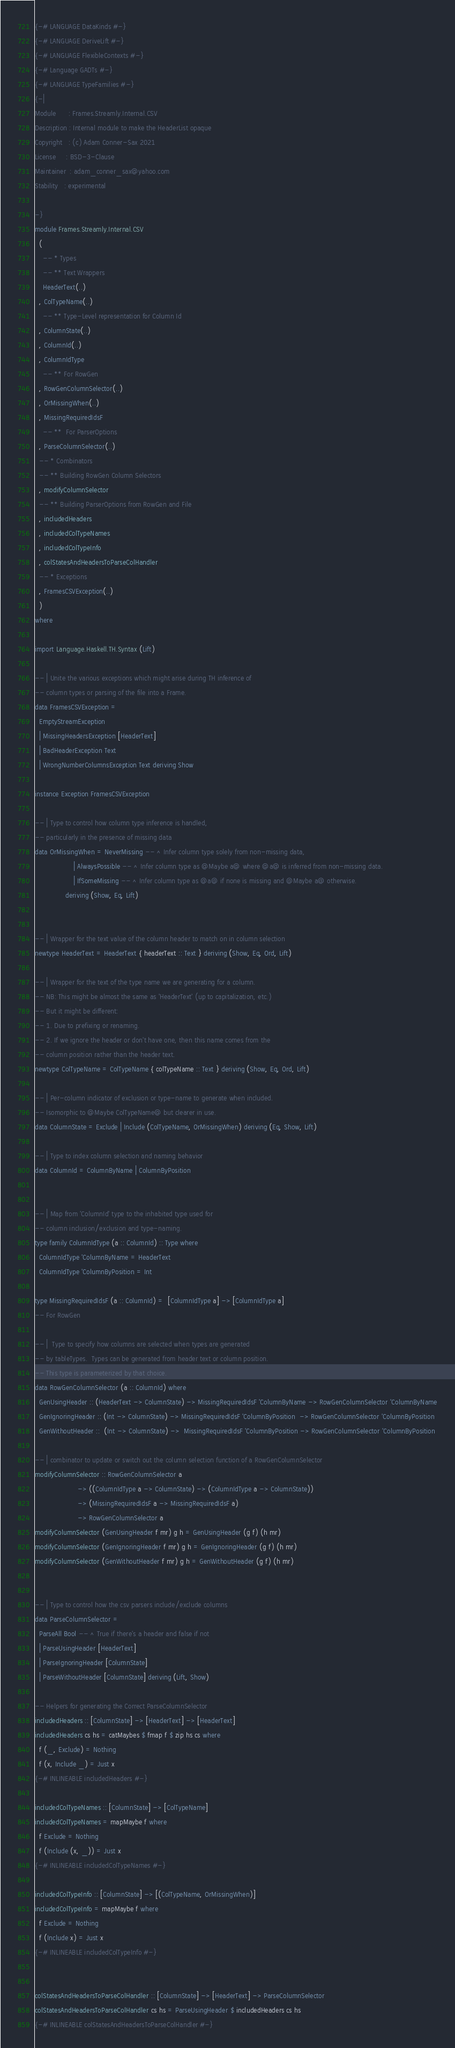Convert code to text. <code><loc_0><loc_0><loc_500><loc_500><_Haskell_>{-# LANGUAGE DataKinds #-}
{-# LANGUAGE DeriveLift #-}
{-# LANGUAGE FlexibleContexts #-}
{-# Language GADTs #-}
{-# LANGUAGE TypeFamilies #-}
{-|
Module      : Frames.Streamly.Internal.CSV
Description : Internal module to make the HeaderList opaque
Copyright   : (c) Adam Conner-Sax 2021
License     : BSD-3-Clause
Maintainer  : adam_conner_sax@yahoo.com
Stability   : experimental

-}
module Frames.Streamly.Internal.CSV
  (
    -- * Types
    -- ** Text Wrappers
    HeaderText(..)
  , ColTypeName(..)
    -- ** Type-Level representation for Column Id
  , ColumnState(..)
  , ColumnId(..)
  , ColumnIdType
    -- ** For RowGen
  , RowGenColumnSelector(..)
  , OrMissingWhen(..)
  , MissingRequiredIdsF
    -- **  For ParserOptions
  , ParseColumnSelector(..)
  -- * Combinators
  -- ** Building RowGen Column Selectors
  , modifyColumnSelector
  -- ** Building ParserOptions from RowGen and File
  , includedHeaders
  , includedColTypeNames
  , includedColTypeInfo
  , colStatesAndHeadersToParseColHandler
  -- * Exceptions
  , FramesCSVException(..)
  )
where

import Language.Haskell.TH.Syntax (Lift)

-- | Unite the various exceptions which might arise during TH inference of
-- column types or parsing of the file into a Frame.
data FramesCSVException =
  EmptyStreamException
  | MissingHeadersException [HeaderText]
  | BadHeaderException Text
  | WrongNumberColumnsException Text deriving Show

instance Exception FramesCSVException

-- | Type to control how column type inference is handled,
-- particularly in the presence of missing data
data OrMissingWhen = NeverMissing -- ^ Infer column type solely from non-missing data,
                   | AlwaysPossible -- ^ Infer column type as @Maybe a@ where @a@ is inferred from non-missing data.
                   | IfSomeMissing -- ^ Infer column type as @a@ if none is missing and @Maybe a@ otherwise.
               deriving (Show, Eq, Lift)


-- | Wrapper for the text value of the column header to match on in column selection
newtype HeaderText = HeaderText { headerText :: Text } deriving (Show, Eq, Ord, Lift)

-- | Wrapper for the text of the type name we are generating for a column.
-- NB: This might be almost the same as 'HeaderText' (up to capitalization, etc.)
-- But it might be different:
-- 1. Due to prefixing or renaming.
-- 2. If we ignore the header or don't have one, then this name comes from the
-- column position rather than the header text.
newtype ColTypeName = ColTypeName { colTypeName :: Text } deriving (Show, Eq, Ord, Lift)

-- | Per-column indicator of exclusion or type-name to generate when included.
-- Isomorphic to @Maybe ColTypeName@ but clearer in use.
data ColumnState = Exclude | Include (ColTypeName, OrMissingWhen) deriving (Eq, Show, Lift)

-- | Type to index column selection and naming behavior
data ColumnId = ColumnByName | ColumnByPosition


-- | Map from 'ColumnId' type to the inhabited type used for
-- column inclusion/exclusion and type-naming.
type family ColumnIdType (a :: ColumnId) :: Type where
  ColumnIdType 'ColumnByName = HeaderText
  ColumnIdType 'ColumnByPosition = Int

type MissingRequiredIdsF (a :: ColumnId) =  [ColumnIdType a] -> [ColumnIdType a]
-- For RowGen

-- |  Type to specify how columns are selected when types are generated
-- by tableTypes.  Types can be generated from header text or column position.
-- This type is parameterized by that choice.
data RowGenColumnSelector (a :: ColumnId) where
  GenUsingHeader :: (HeaderText -> ColumnState) -> MissingRequiredIdsF 'ColumnByName -> RowGenColumnSelector 'ColumnByName
  GenIgnoringHeader :: (Int -> ColumnState) -> MissingRequiredIdsF 'ColumnByPosition  -> RowGenColumnSelector 'ColumnByPosition
  GenWithoutHeader ::  (Int -> ColumnState) ->  MissingRequiredIdsF 'ColumnByPosition -> RowGenColumnSelector 'ColumnByPosition

-- | combinator to update or switch out the column selection function of a RowGenColumnSelector
modifyColumnSelector :: RowGenColumnSelector a
                     -> ((ColumnIdType a -> ColumnState) -> (ColumnIdType a -> ColumnState))
                     -> (MissingRequiredIdsF a -> MissingRequiredIdsF a)
                     -> RowGenColumnSelector a
modifyColumnSelector (GenUsingHeader f mr) g h = GenUsingHeader (g f) (h mr)
modifyColumnSelector (GenIgnoringHeader f mr) g h = GenIgnoringHeader (g f) (h mr)
modifyColumnSelector (GenWithoutHeader f mr) g h = GenWithoutHeader (g f) (h mr)


-- | Type to control how the csv parsers include/exclude columns
data ParseColumnSelector =
  ParseAll Bool -- ^ True if there's a header and false if not
  | ParseUsingHeader [HeaderText]
  | ParseIgnoringHeader [ColumnState]
  | ParseWithoutHeader [ColumnState] deriving (Lift, Show)

-- Helpers for generating the Correct ParseColumnSelector
includedHeaders :: [ColumnState] -> [HeaderText] -> [HeaderText]
includedHeaders cs hs = catMaybes $ fmap f $ zip hs cs where
  f (_, Exclude) = Nothing
  f (x, Include _) = Just x
{-# INLINEABLE includedHeaders #-}

includedColTypeNames :: [ColumnState] -> [ColTypeName]
includedColTypeNames = mapMaybe f where
  f Exclude = Nothing
  f (Include (x, _)) = Just x
{-# INLINEABLE includedColTypeNames #-}

includedColTypeInfo :: [ColumnState] -> [(ColTypeName, OrMissingWhen)]
includedColTypeInfo = mapMaybe f where
  f Exclude = Nothing
  f (Include x) = Just x
{-# INLINEABLE includedColTypeInfo #-}


colStatesAndHeadersToParseColHandler :: [ColumnState] -> [HeaderText] -> ParseColumnSelector
colStatesAndHeadersToParseColHandler cs hs = ParseUsingHeader $ includedHeaders cs hs
{-# INLINEABLE colStatesAndHeadersToParseColHandler #-}
</code> 